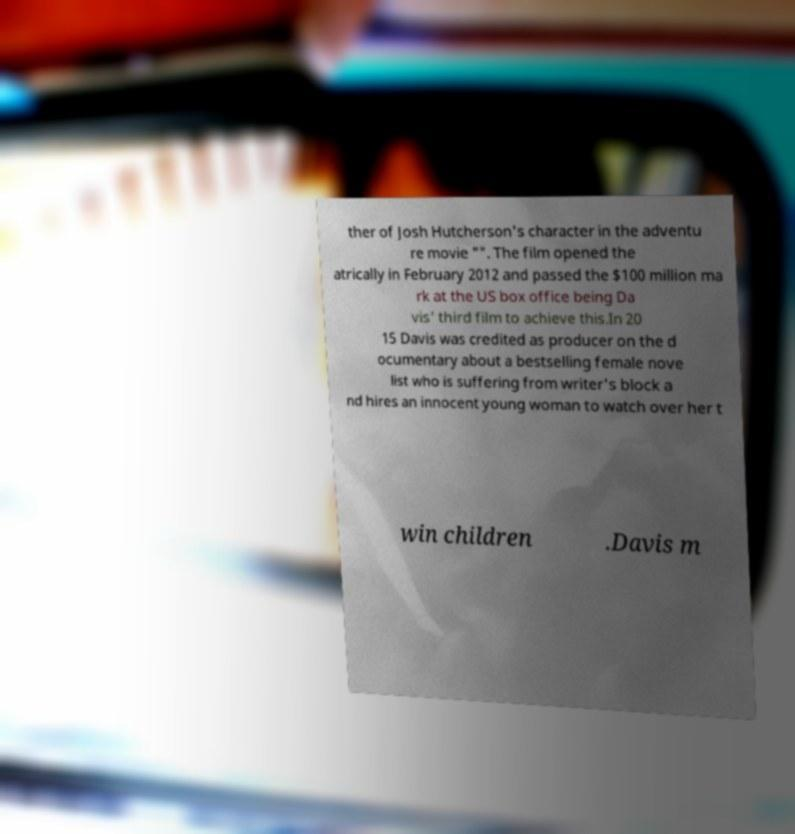There's text embedded in this image that I need extracted. Can you transcribe it verbatim? ther of Josh Hutcherson's character in the adventu re movie "". The film opened the atrically in February 2012 and passed the $100 million ma rk at the US box office being Da vis' third film to achieve this.In 20 15 Davis was credited as producer on the d ocumentary about a bestselling female nove list who is suffering from writer's block a nd hires an innocent young woman to watch over her t win children .Davis m 